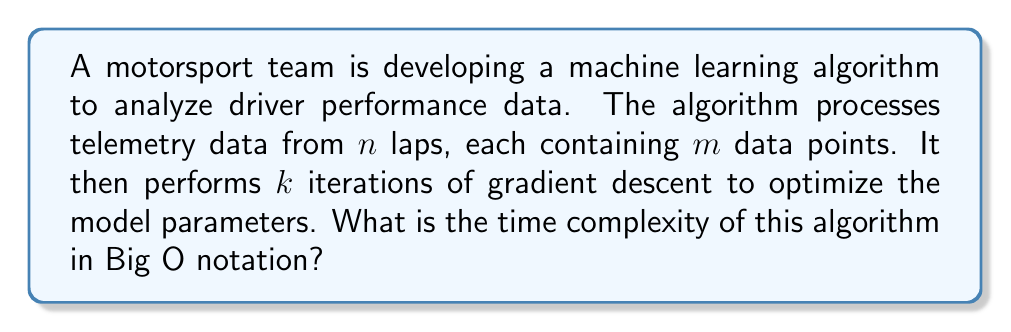Can you answer this question? To determine the time complexity of this algorithm, we need to break it down into its components and analyze each step:

1. Data processing:
   - The algorithm processes $n$ laps, each with $m$ data points.
   - This step has a time complexity of $O(nm)$.

2. Gradient descent:
   - The algorithm performs $k$ iterations of gradient descent.
   - In each iteration, it needs to process all $nm$ data points.
   - This step has a time complexity of $O(knm)$.

3. Additional operations:
   - We can assume that there are some constant-time operations for initialization and finalization.
   - These operations have a time complexity of $O(1)$.

Now, we combine these components:

$$O(nm) + O(knm) + O(1)$$

Since we're interested in the asymptotic behavior, we can simplify this expression:

1. $O(1)$ is negligible compared to the other terms, so we can drop it.
2. $O(nm)$ is dominated by $O(knm)$ when $k > 1$, which is typically the case in machine learning algorithms.

Therefore, the overall time complexity of the algorithm is:

$$O(knm)$$

This means that the algorithm's running time grows linearly with the number of gradient descent iterations $(k)$, the number of laps $(n)$, and the number of data points per lap $(m)$.

For an aspiring engineer in motorsports, understanding this complexity is crucial for optimizing the algorithm's performance, especially when dealing with large datasets from multiple races or when real-time analysis is required.
Answer: $O(knm)$ 